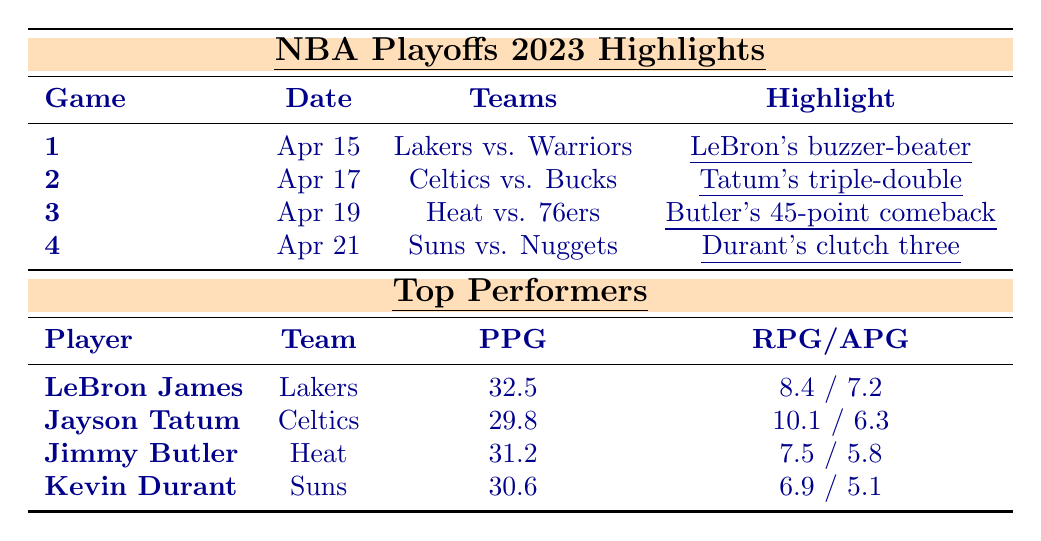What was the highlight of Game 1 in the playoffs? According to the table, in Game 1, LeBron James scored a buzzer-beater to win the game for the Lakers against the Warriors.
Answer: LeBron's buzzer-beater Which player had the highest points per game in the playoffs? Looking at the top performers, LeBron James scored an average of 32.5 points per game, which is the highest among all listed players.
Answer: LeBron James How many points did Jimmy Butler score in his playoff game? The table specifies that Jimmy Butler scored 45 points in his game against the Philadelphia 76ers.
Answer: 45 points Did Kevin Durant achieve a double-digit rebound average? The table shows Kevin Durant had an average of 6.9 rebounds per game, which is less than ten. Hence, he did not achieve a double-digit rebound average.
Answer: No What is the combined points per game for the top two performers? LeBron James scored an average of 32.5 points, and Jayson Tatum scored 29.8 points. Adding these gives 32.5 + 29.8 = 62.3 points per game total for the top two performers.
Answer: 62.3 points Which two teams played on April 21, 2023, and what was the highlight of that game? The table indicates that the Phoenix Suns played against the Denver Nuggets, and the highlight was Kevin Durant hitting a clutch three-pointer to secure the victory.
Answer: Suns vs. Nuggets; Durant's clutch three What is the average assists per game for the top performers in the playoffs? Adding their assists per game: 7.2 (LeBron) + 6.3 (Tatum) + 5.8 (Butler) + 5.1 (Durant) = 24.4. There are four players, so the average is 24.4 / 4 = 6.1 assists per game.
Answer: 6.1 assists Which player notched a triple-double, and for which team did he play? The table states that Jayson Tatum recorded a triple-double while playing for the Boston Celtics.
Answer: Jayson Tatum; Celtics What was the highlight of Game 3, and how did it relate to the team's performance? Game 3 featured Jimmy Butler scoring 45 points, helping the Miami Heat overcome a significant 20-point deficit. This performance directly contributed to the team's comeback victory.
Answer: Butler's 45-point comeback How many total points did the top three performers score, on average? The top three performers scored: LeBron (32.5), Jayson (29.8), and Jimmy (31.2), which totals to 32.5 + 29.8 + 31.2 = 93.5 points. Dividing this by 3 gives an average of 31.17 points.
Answer: 31.17 points 